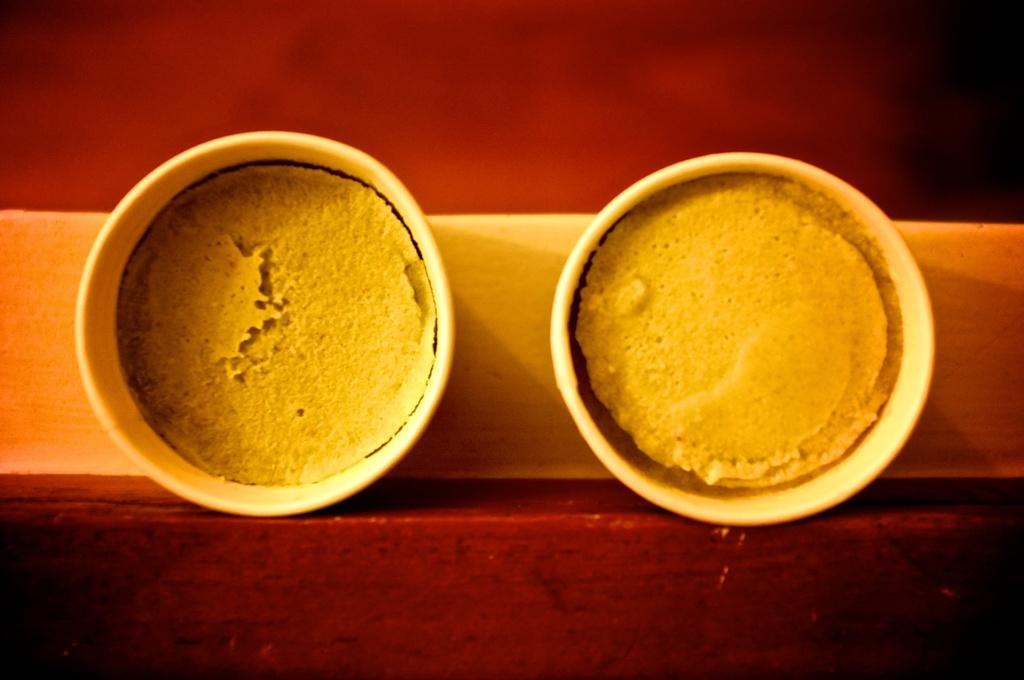How many cups are visible in the image? There are two cups in the image. What is inside the cups? The cups have a food item in them. Where are the cups located? The cups are placed on a table. What type of church is depicted in the image? There is no church present in the image; it only features two cups with a food item in them. 